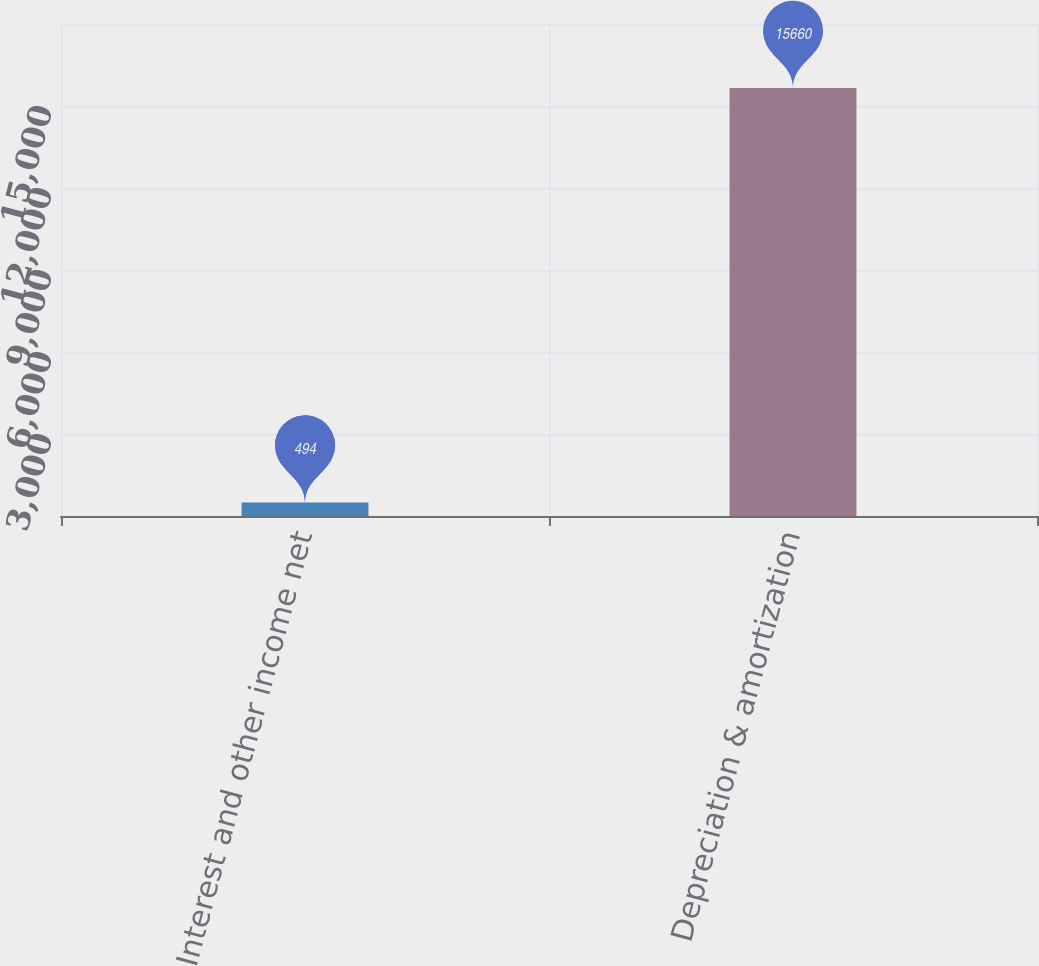Convert chart. <chart><loc_0><loc_0><loc_500><loc_500><bar_chart><fcel>Interest and other income net<fcel>Depreciation & amortization<nl><fcel>494<fcel>15660<nl></chart> 